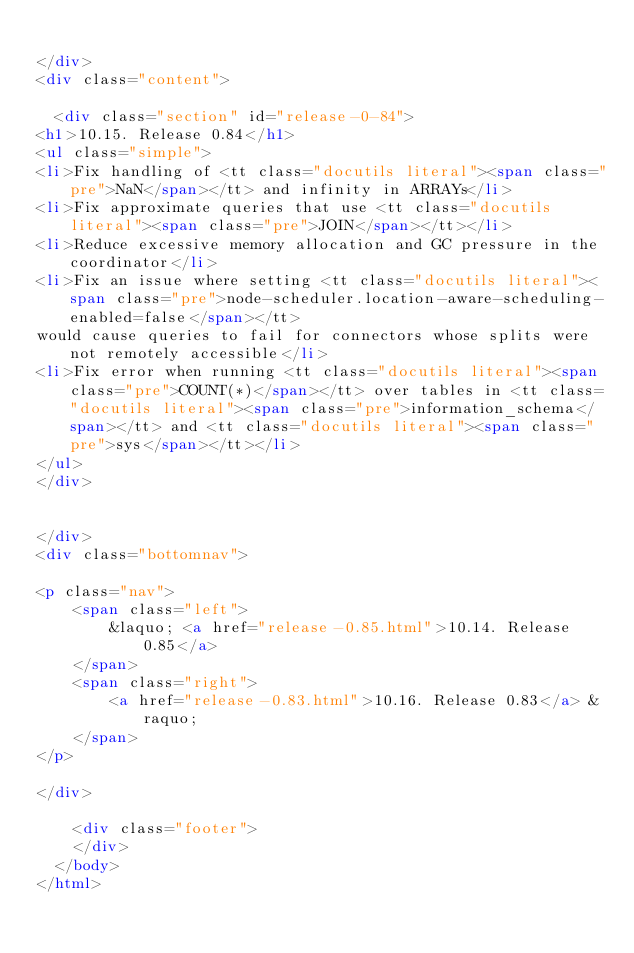Convert code to text. <code><loc_0><loc_0><loc_500><loc_500><_HTML_>
</div>
<div class="content">
    
  <div class="section" id="release-0-84">
<h1>10.15. Release 0.84</h1>
<ul class="simple">
<li>Fix handling of <tt class="docutils literal"><span class="pre">NaN</span></tt> and infinity in ARRAYs</li>
<li>Fix approximate queries that use <tt class="docutils literal"><span class="pre">JOIN</span></tt></li>
<li>Reduce excessive memory allocation and GC pressure in the coordinator</li>
<li>Fix an issue where setting <tt class="docutils literal"><span class="pre">node-scheduler.location-aware-scheduling-enabled=false</span></tt>
would cause queries to fail for connectors whose splits were not remotely accessible</li>
<li>Fix error when running <tt class="docutils literal"><span class="pre">COUNT(*)</span></tt> over tables in <tt class="docutils literal"><span class="pre">information_schema</span></tt> and <tt class="docutils literal"><span class="pre">sys</span></tt></li>
</ul>
</div>


</div>
<div class="bottomnav">
    
<p class="nav">
    <span class="left">
        &laquo; <a href="release-0.85.html">10.14. Release 0.85</a>
    </span>
    <span class="right">
        <a href="release-0.83.html">10.16. Release 0.83</a> &raquo;
    </span>
</p>

</div>

    <div class="footer">
    </div>
  </body>
</html></code> 